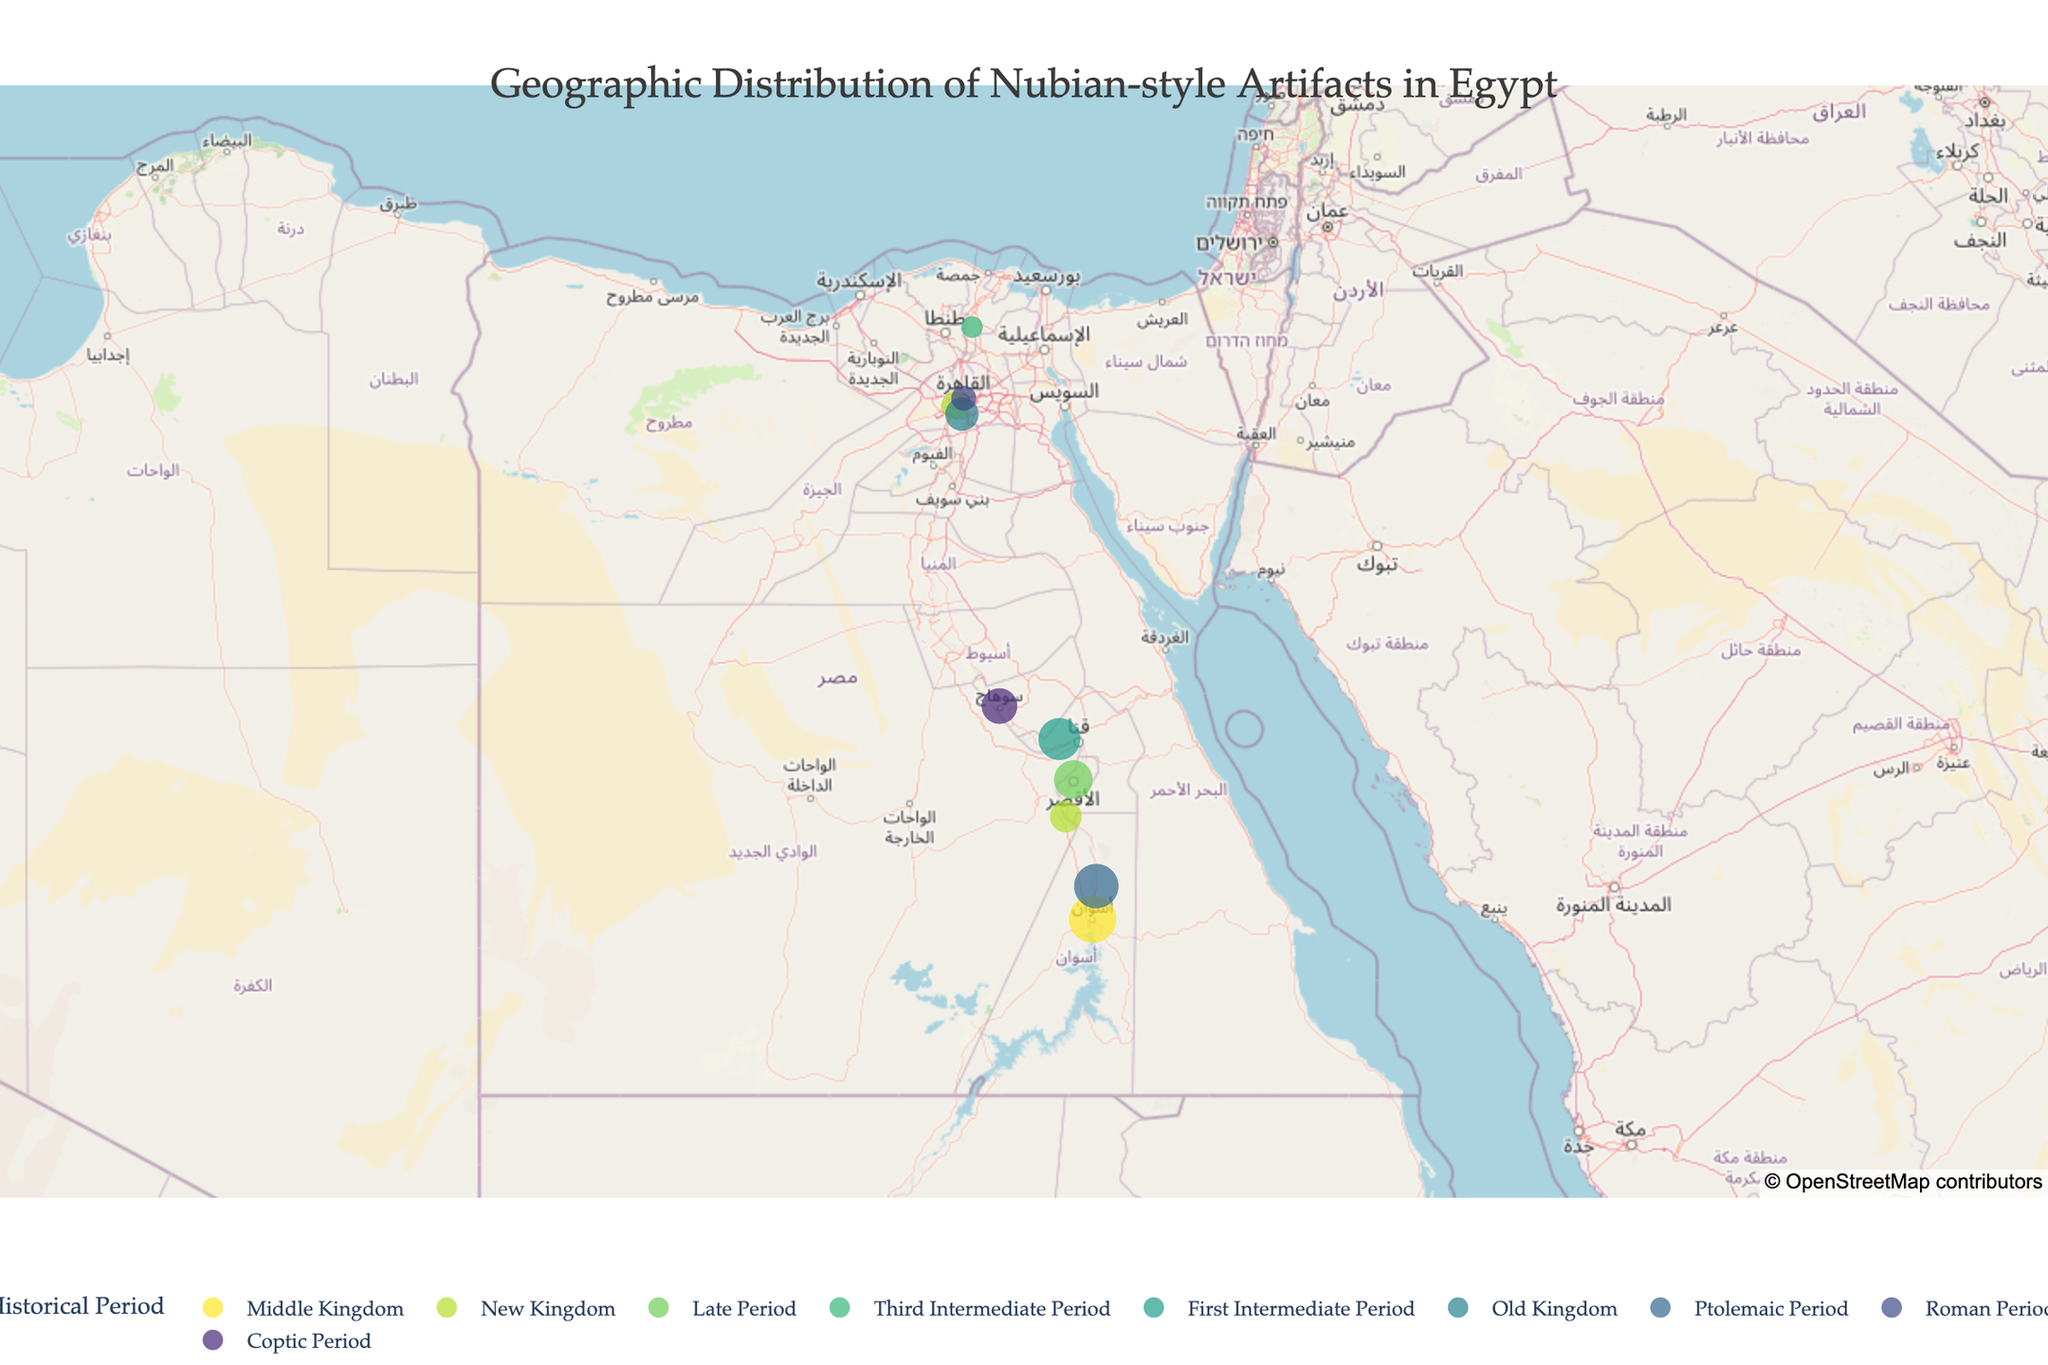What's the title of the plot? The title of the plot is mentioned at the top and it helps to understand what the visual represents. By glancing at the top of the figure, we can see the title.
Answer: Geographic Distribution of Nubian-style Artifacts in Egypt How many total sites are represented on the map? By counting all the distinct location markers present on the map, we can determine the number of sites.
Answer: 10 Which site has the highest quantity of Nubian-style artifacts, and how many does it have? To find this, we look for the marker with the largest size, which represents the highest quantity. According to the size legend in the plot, we identify the site name and quantity of artifacts from the hover text.
Answer: Aswan, 42 Among all the periods represented, which one has the most diverse artifact types? We need to count the unique artifact types for each historical period and find the period with the highest count. From the plot, we hover over each marker and note down the artifact types per period.
Answer: New Kingdom Which period shows the most widespread geographic influence of Nubian-style artifacts? To determine this, we count the number of distinct geographic sites (locations) within each period by hovering over the markers and noting the period tags. The period with markers at the most diverse geographic locations has the most widespread influence.
Answer: New Kingdom How many artifact types are found exclusively in the New Kingdom period? Hover over the markers coded with the New Kingdom period and list all the artifact types found. Then cross-check with other periods to see how many of these types appear solely in the New Kingdom.
Answer: 2 (Nubian Jewelry, Nubian Cosmetic Items) Which two sites are geographically the closest to each other and what artifact types do they contain? By closely observing the markers' positions on the map and comparison of their latitudes and longitudes, identify the two sites that are nearest. Hover over them to reveal their artifact types.
Answer: Aswan (Nubian Pottery) and Kom Ombo (Nubian Tools) What type of artifact has the second highest quantity, and at which site is it found? Order all the quantities and find the one with the second-largest value. Note down the associated artifact type and site by hovering over the markers.
Answer: Nubian Amulets, Abydos Compare the quantity of Nubian-style artifacts found in Giza and Saqqara during their respective periods. Which site has more, and by how much? Hover over the markers at Giza and Saqqara to find the quantities. Subtract the smaller quantity from the larger one and determine which site has more artifacts.
Answer: Saqqara has more by 6 (21 - 15 = 6) What is the average quantity of artifacts found per site in the data provided? Sum all quantities of artifacts from each site (42 + 15 + 28 + 9 + 33 + 21 + 37 + 12 + 19 + 24 = 240). Divide this sum by the number of sites (10).
Answer: 24 